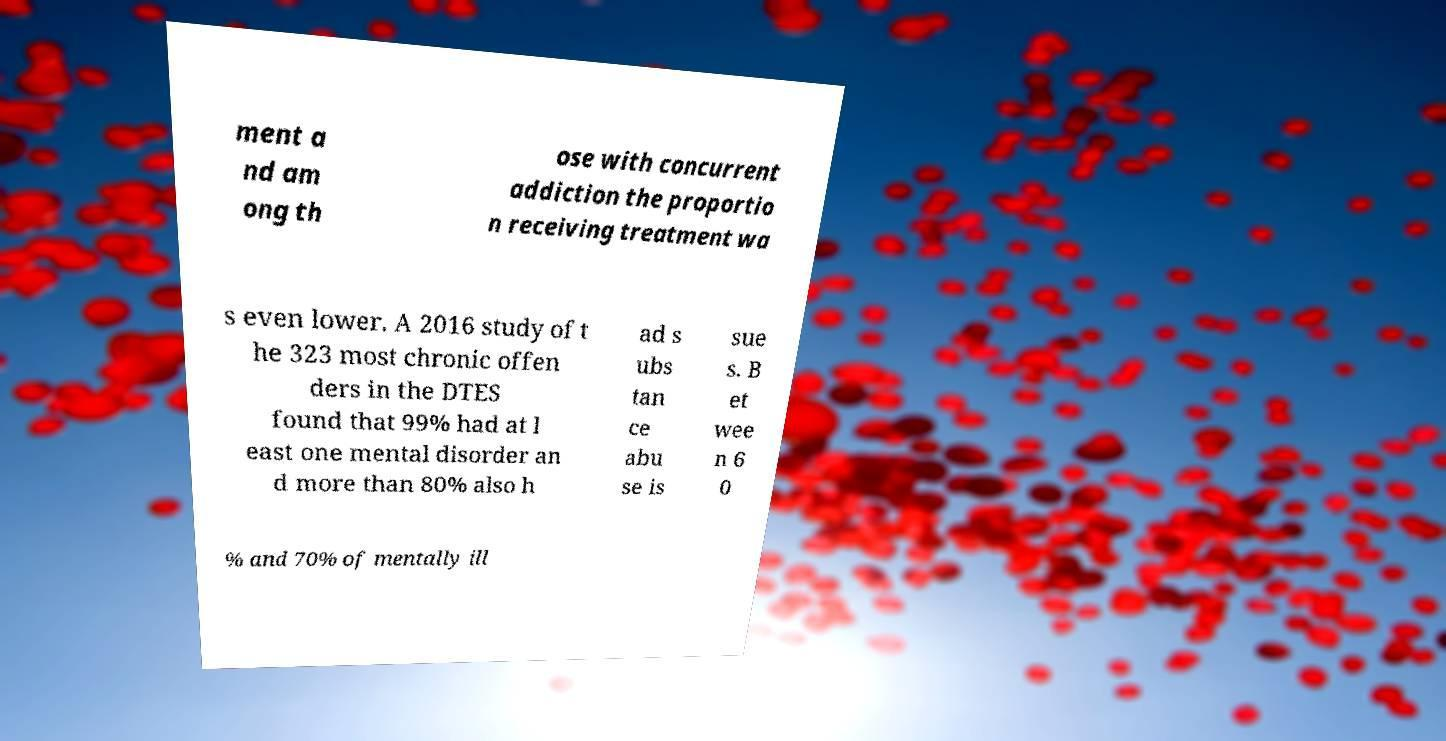Can you accurately transcribe the text from the provided image for me? ment a nd am ong th ose with concurrent addiction the proportio n receiving treatment wa s even lower. A 2016 study of t he 323 most chronic offen ders in the DTES found that 99% had at l east one mental disorder an d more than 80% also h ad s ubs tan ce abu se is sue s. B et wee n 6 0 % and 70% of mentally ill 